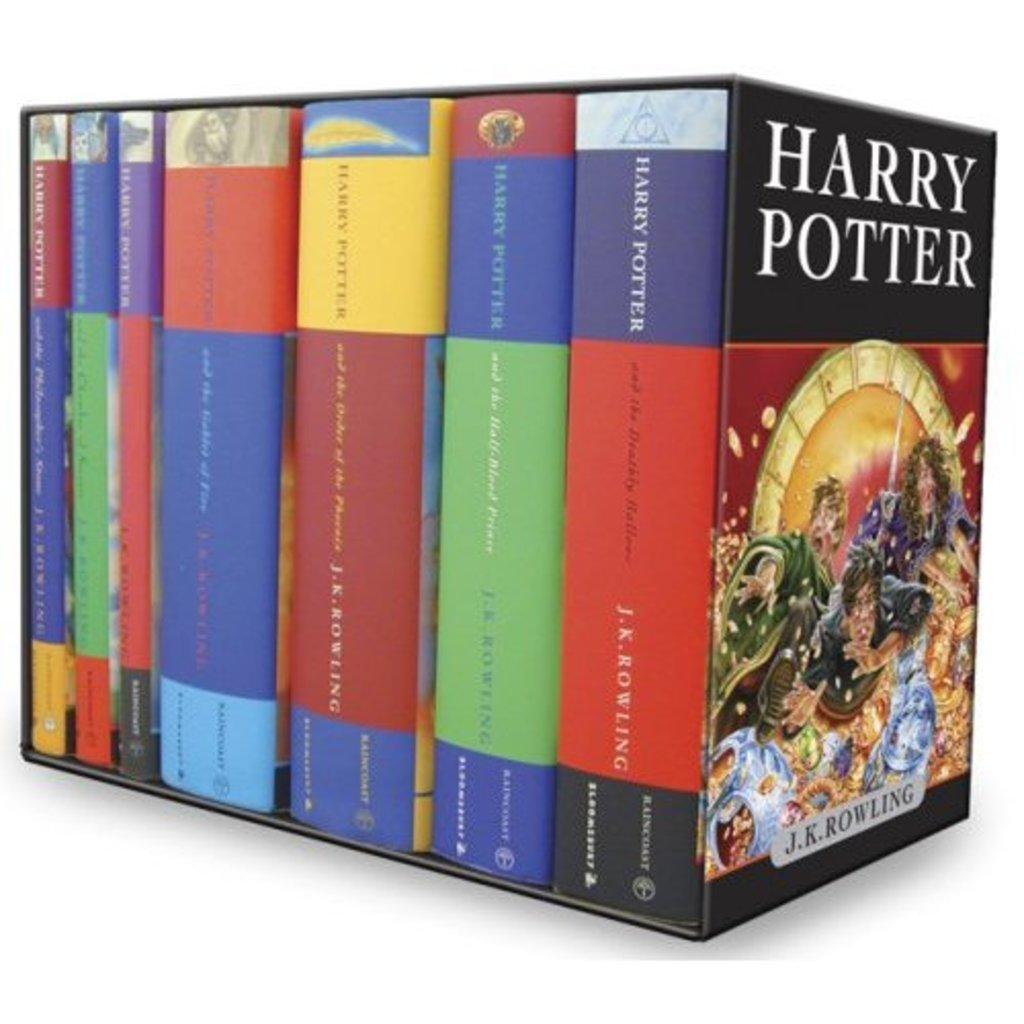What is the title of the book farthest to the right?
Provide a succinct answer. Harry potter. 